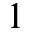<formula> <loc_0><loc_0><loc_500><loc_500>1</formula> 